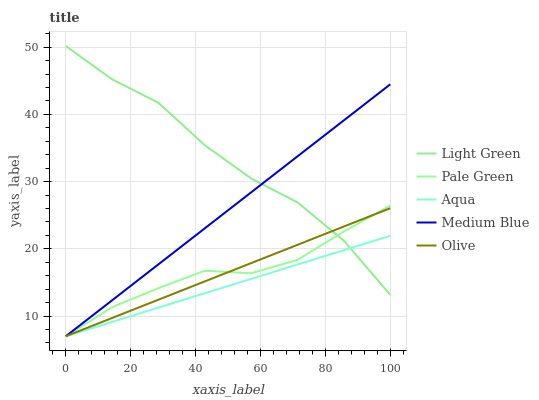Does Aqua have the minimum area under the curve?
Answer yes or no. Yes. Does Light Green have the maximum area under the curve?
Answer yes or no. Yes. Does Medium Blue have the minimum area under the curve?
Answer yes or no. No. Does Medium Blue have the maximum area under the curve?
Answer yes or no. No. Is Olive the smoothest?
Answer yes or no. Yes. Is Light Green the roughest?
Answer yes or no. Yes. Is Medium Blue the smoothest?
Answer yes or no. No. Is Medium Blue the roughest?
Answer yes or no. No. Does Olive have the lowest value?
Answer yes or no. Yes. Does Light Green have the lowest value?
Answer yes or no. No. Does Light Green have the highest value?
Answer yes or no. Yes. Does Medium Blue have the highest value?
Answer yes or no. No. Does Medium Blue intersect Pale Green?
Answer yes or no. Yes. Is Medium Blue less than Pale Green?
Answer yes or no. No. Is Medium Blue greater than Pale Green?
Answer yes or no. No. 